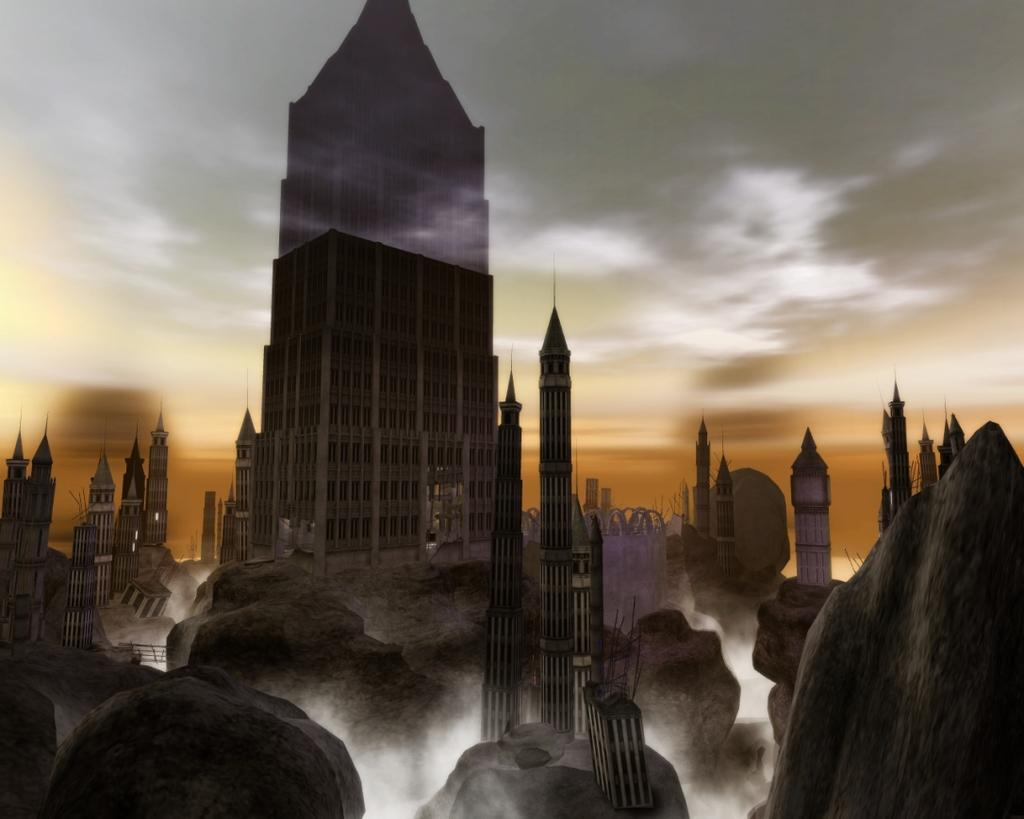Describe this image in one or two sentences. At the bottom of the image there are rocks with towers. In the middle of the image there is a building with windows. And in the background there is a sky. 